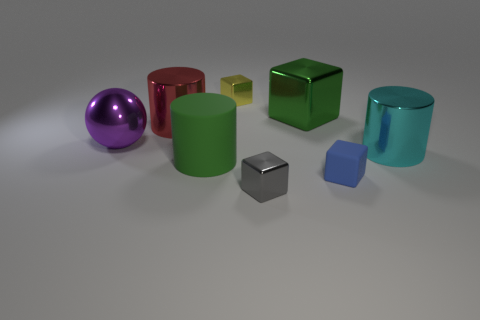Subtract 1 blocks. How many blocks are left? 3 Add 1 green cylinders. How many objects exist? 9 Subtract all cylinders. How many objects are left? 5 Subtract all big cylinders. Subtract all yellow rubber balls. How many objects are left? 5 Add 8 large red metal things. How many large red metal things are left? 9 Add 4 large purple matte cylinders. How many large purple matte cylinders exist? 4 Subtract 1 cyan cylinders. How many objects are left? 7 